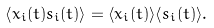Convert formula to latex. <formula><loc_0><loc_0><loc_500><loc_500>\left \langle x _ { i } ( t ) s _ { i } ( t ) \right \rangle = \langle x _ { i } ( t ) \rangle \langle s _ { i } ( t ) \rangle .</formula> 